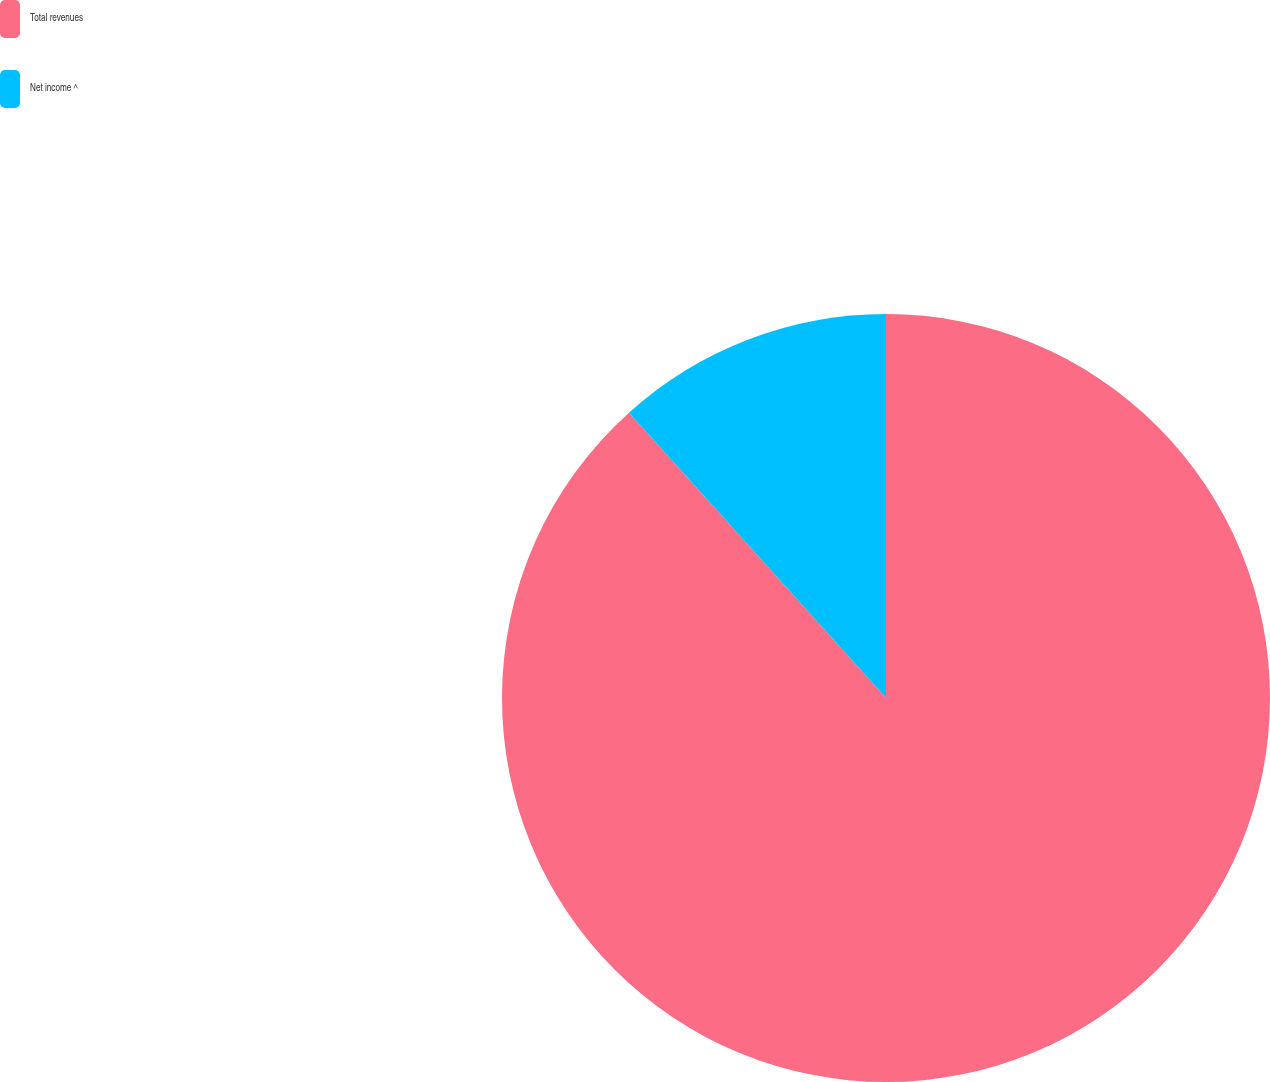<chart> <loc_0><loc_0><loc_500><loc_500><pie_chart><fcel>Total revenues<fcel>Net income ^<nl><fcel>88.33%<fcel>11.67%<nl></chart> 